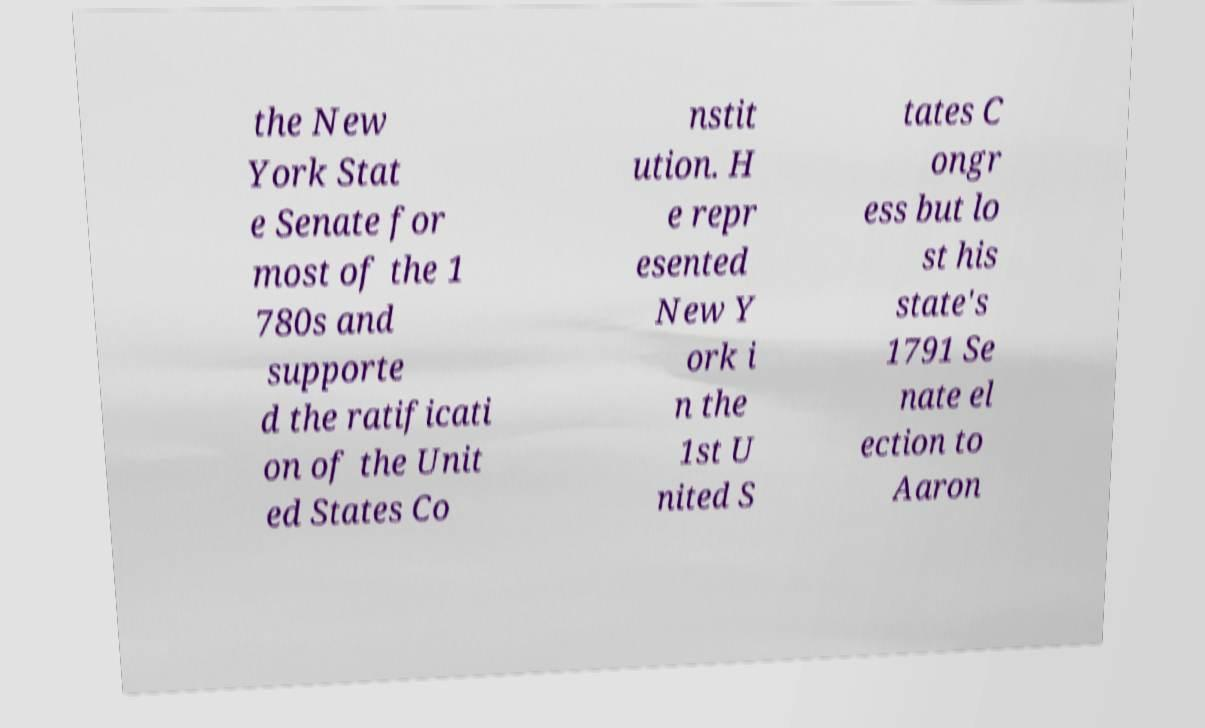Could you extract and type out the text from this image? the New York Stat e Senate for most of the 1 780s and supporte d the ratificati on of the Unit ed States Co nstit ution. H e repr esented New Y ork i n the 1st U nited S tates C ongr ess but lo st his state's 1791 Se nate el ection to Aaron 